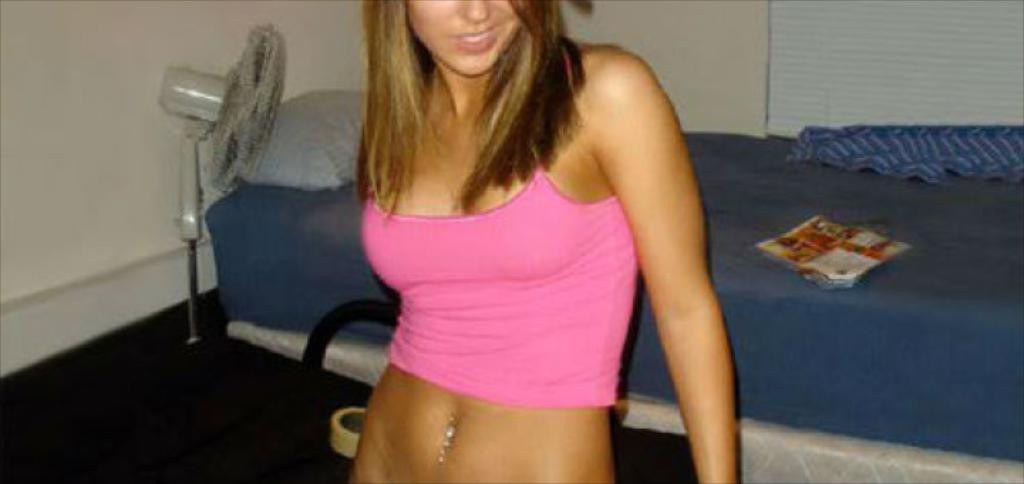Who is present in the image? There is a woman in the picture. What is the woman doing in the image? The woman is standing in front of a bed. What is the woman wearing in the image? The woman is wearing a pink top. What can be seen behind the woman in the image? There is a table fan behind the woman. What type of bomb is visible on the bed in the image? There is no bomb present in the image; it features a woman standing in front of a bed. Can you read the note that the woman is holding in the image? There is no note visible in the image; the woman is not holding anything. 